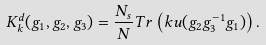<formula> <loc_0><loc_0><loc_500><loc_500>K _ { k } ^ { d } ( g _ { 1 } , g _ { 2 } , g _ { 3 } ) = \frac { N _ { s } } { N } T r \left ( k u ( g _ { 2 } g _ { 3 } ^ { - 1 } g _ { 1 } ) \right ) .</formula> 